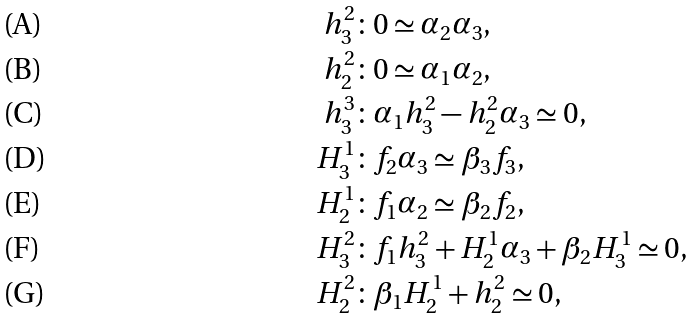<formula> <loc_0><loc_0><loc_500><loc_500>h _ { 3 } ^ { 2 } & \colon 0 \simeq \alpha _ { 2 } \alpha _ { 3 } , \\ h _ { 2 } ^ { 2 } & \colon 0 \simeq \alpha _ { 1 } \alpha _ { 2 } , \\ h _ { 3 } ^ { 3 } & \colon \alpha _ { 1 } h _ { 3 } ^ { 2 } - h _ { 2 } ^ { 2 } \alpha _ { 3 } \simeq 0 , \\ H _ { 3 } ^ { 1 } & \colon f _ { 2 } \alpha _ { 3 } \simeq \beta _ { 3 } f _ { 3 } , \\ H _ { 2 } ^ { 1 } & \colon f _ { 1 } \alpha _ { 2 } \simeq \beta _ { 2 } f _ { 2 } , \\ H _ { 3 } ^ { 2 } & \colon f _ { 1 } h _ { 3 } ^ { 2 } + H _ { 2 } ^ { 1 } \alpha _ { 3 } + \beta _ { 2 } H _ { 3 } ^ { 1 } \simeq 0 , \\ H _ { 2 } ^ { 2 } & \colon \beta _ { 1 } H _ { 2 } ^ { 1 } + h _ { 2 } ^ { 2 } \simeq 0 ,</formula> 